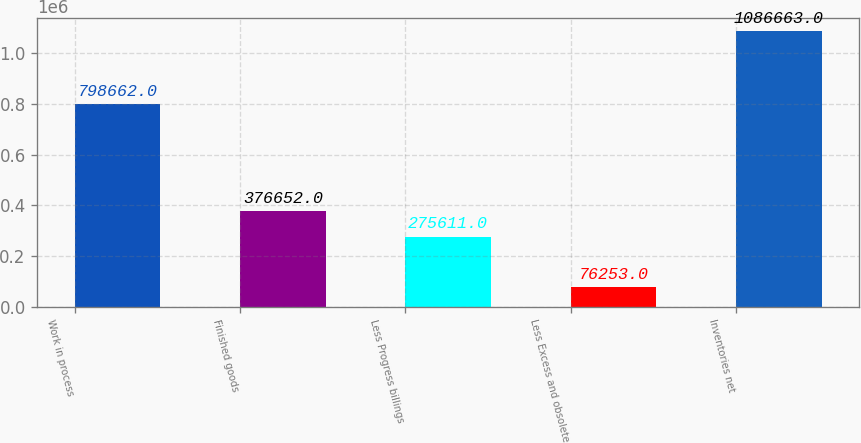<chart> <loc_0><loc_0><loc_500><loc_500><bar_chart><fcel>Work in process<fcel>Finished goods<fcel>Less Progress billings<fcel>Less Excess and obsolete<fcel>Inventories net<nl><fcel>798662<fcel>376652<fcel>275611<fcel>76253<fcel>1.08666e+06<nl></chart> 